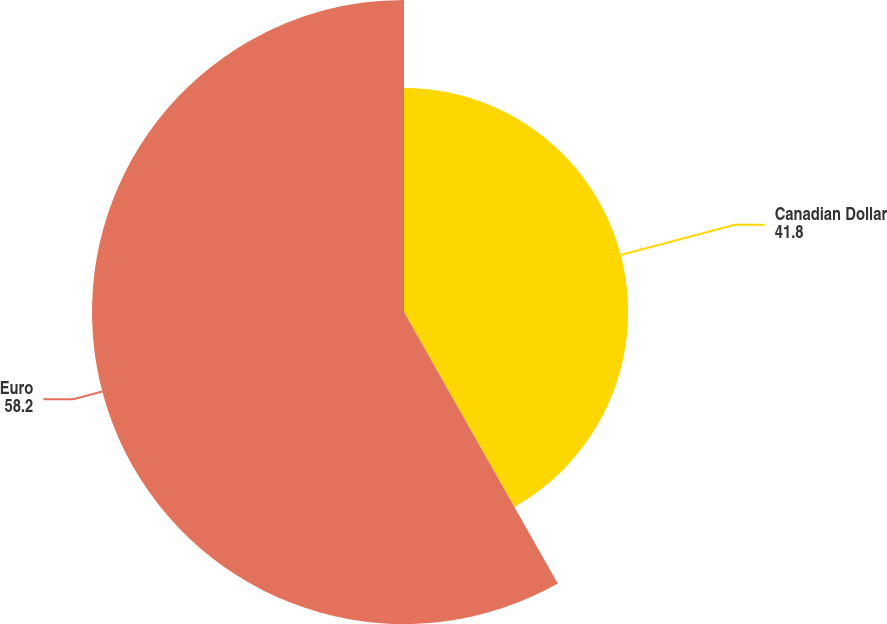Convert chart. <chart><loc_0><loc_0><loc_500><loc_500><pie_chart><fcel>Canadian Dollar<fcel>Euro<nl><fcel>41.8%<fcel>58.2%<nl></chart> 